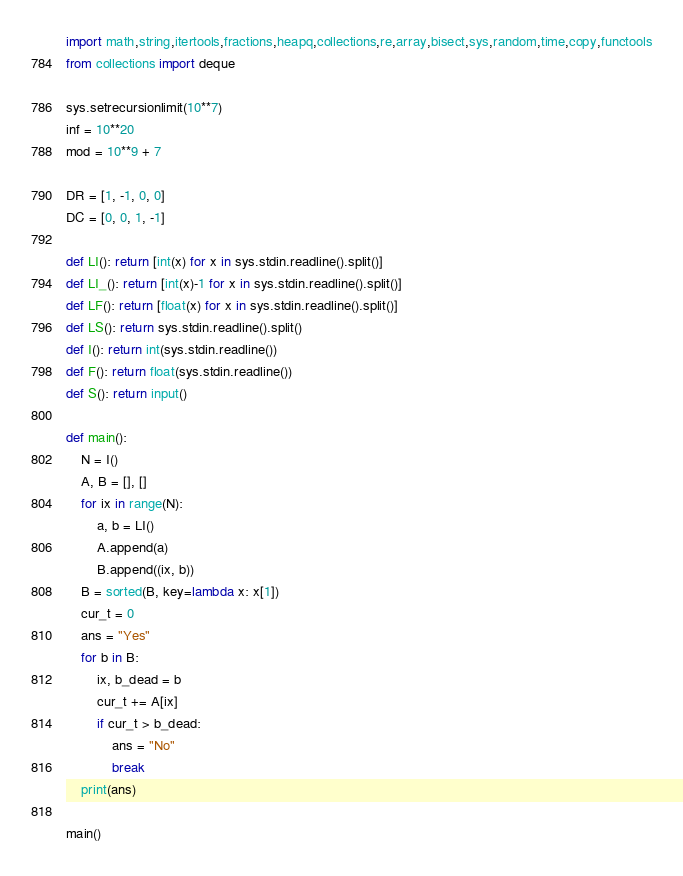Convert code to text. <code><loc_0><loc_0><loc_500><loc_500><_Python_>import math,string,itertools,fractions,heapq,collections,re,array,bisect,sys,random,time,copy,functools
from collections import deque

sys.setrecursionlimit(10**7)
inf = 10**20
mod = 10**9 + 7

DR = [1, -1, 0, 0]
DC = [0, 0, 1, -1]

def LI(): return [int(x) for x in sys.stdin.readline().split()]
def LI_(): return [int(x)-1 for x in sys.stdin.readline().split()]
def LF(): return [float(x) for x in sys.stdin.readline().split()]
def LS(): return sys.stdin.readline().split()
def I(): return int(sys.stdin.readline())
def F(): return float(sys.stdin.readline())
def S(): return input()
     
def main():
    N = I()
    A, B = [], []
    for ix in range(N):
        a, b = LI()
        A.append(a)
        B.append((ix, b))
    B = sorted(B, key=lambda x: x[1])
    cur_t = 0
    ans = "Yes"
    for b in B:
        ix, b_dead = b
        cur_t += A[ix]
        if cur_t > b_dead:
            ans = "No"
            break
    print(ans)

main()

</code> 